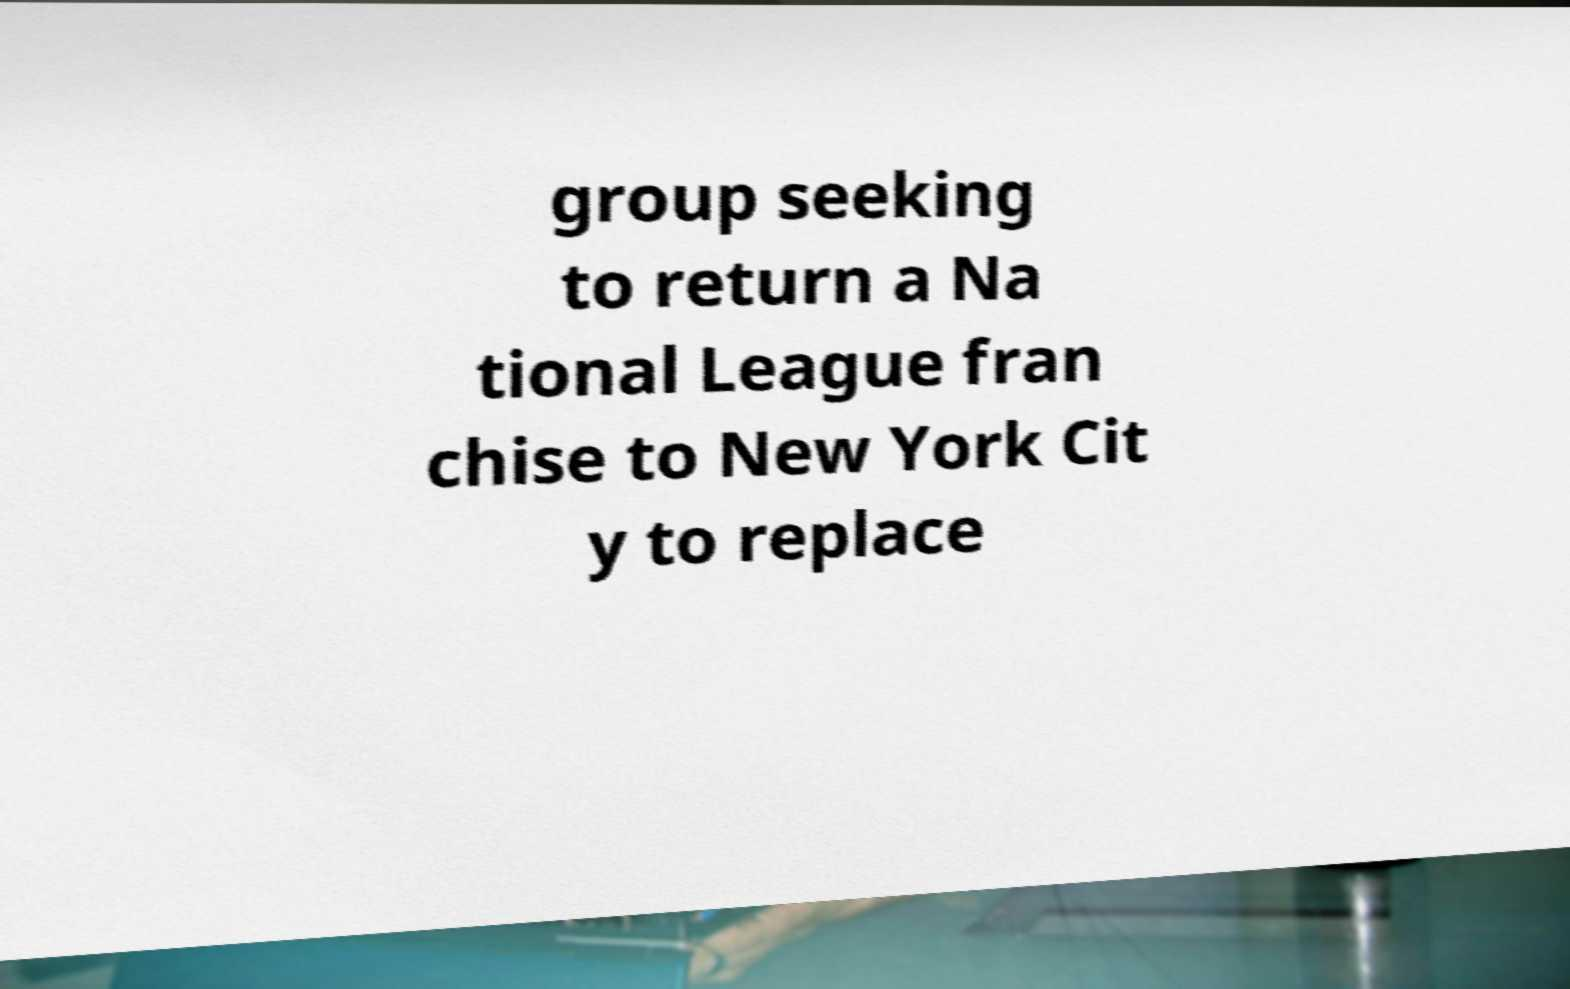What messages or text are displayed in this image? I need them in a readable, typed format. group seeking to return a Na tional League fran chise to New York Cit y to replace 